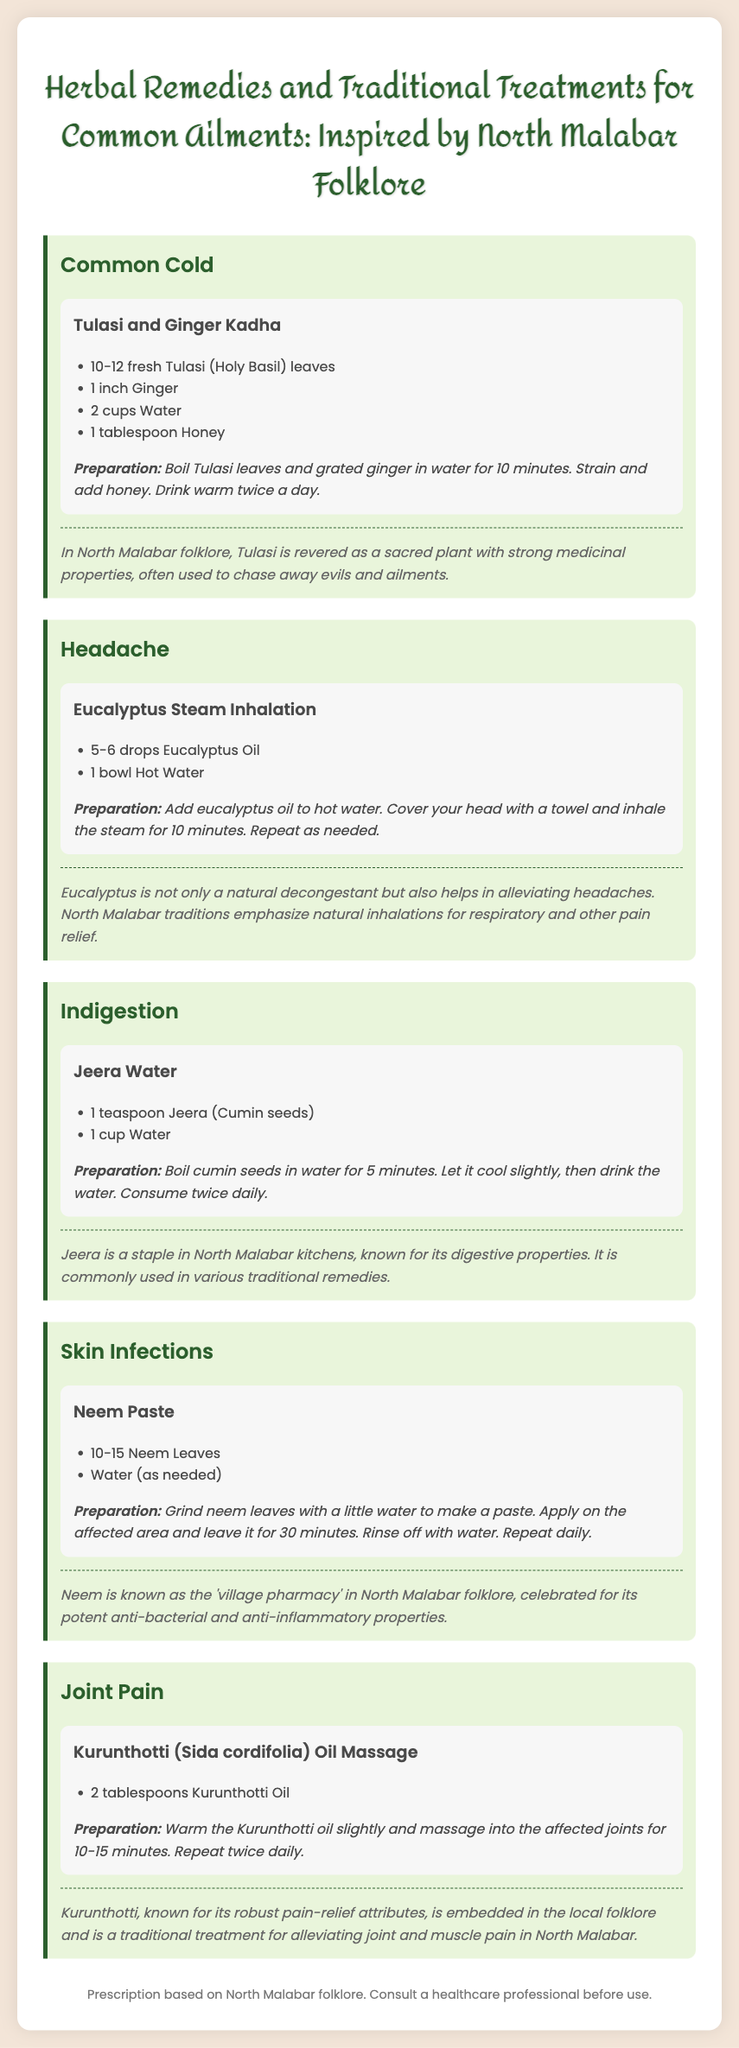What is the first remedy for Common Cold? The first remedy listed for Common Cold is Tulasi and Ginger Kadha.
Answer: Tulasi and Ginger Kadha How many Tulasi leaves are used in the remedy for Common Cold? The remedy for Common Cold requires 10-12 fresh Tulasi leaves.
Answer: 10-12 fresh Tulasi leaves What is the preparation time for Jeera Water? The preparation time for Jeera Water is 5 minutes for boiling the cumin seeds.
Answer: 5 minutes What is the main ingredient in the remedy for skin infections? The main ingredient in the remedy for skin infections is Neem Leaves.
Answer: Neem Leaves How often should Kurunthotti oil be used for joint pain? Kurunthotti oil should be used twice daily for joint pain.
Answer: Twice daily What is the medicinal property emphasized for Tulasi in folklore? Tulasi is revered for its strong medicinal properties and is often used to chase away evils and ailments.
Answer: Strong medicinal properties What is suggested to treat headaches according to the document? Eucalyptus Steam Inhalation is suggested to treat headaches.
Answer: Eucalyptus Steam Inhalation Which ailment can be treated with Jeera Water? Jeera Water is used to treat Indigestion.
Answer: Indigestion What should you do after applying Neem paste? After applying Neem paste, you should leave it for 30 minutes and then rinse off with water.
Answer: Leave for 30 minutes and rinse off with water 